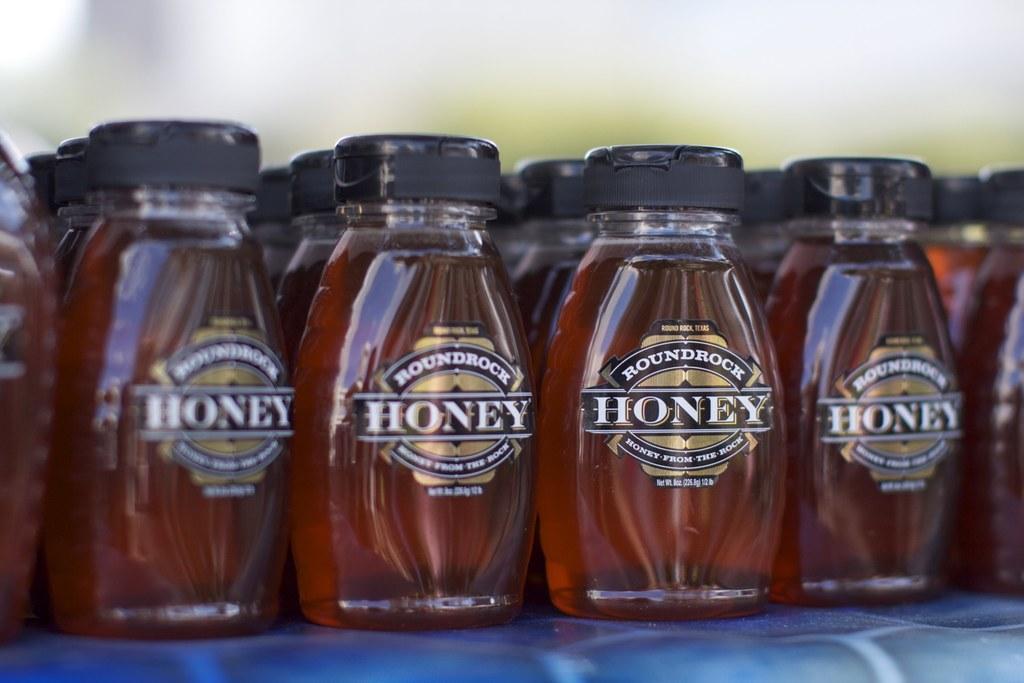How would you summarize this image in a sentence or two? In the image there are few honey bottles on the table. 